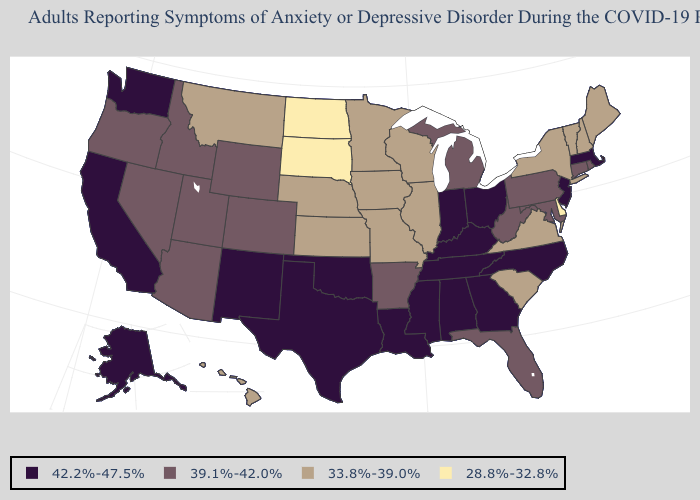Among the states that border Tennessee , does Virginia have the highest value?
Give a very brief answer. No. Which states have the lowest value in the South?
Give a very brief answer. Delaware. Is the legend a continuous bar?
Be succinct. No. How many symbols are there in the legend?
Quick response, please. 4. Which states have the highest value in the USA?
Keep it brief. Alabama, Alaska, California, Georgia, Indiana, Kentucky, Louisiana, Massachusetts, Mississippi, New Jersey, New Mexico, North Carolina, Ohio, Oklahoma, Tennessee, Texas, Washington. Name the states that have a value in the range 39.1%-42.0%?
Give a very brief answer. Arizona, Arkansas, Colorado, Connecticut, Florida, Idaho, Maryland, Michigan, Nevada, Oregon, Pennsylvania, Rhode Island, Utah, West Virginia, Wyoming. What is the value of New Mexico?
Answer briefly. 42.2%-47.5%. Name the states that have a value in the range 28.8%-32.8%?
Be succinct. Delaware, North Dakota, South Dakota. Does the first symbol in the legend represent the smallest category?
Concise answer only. No. Name the states that have a value in the range 39.1%-42.0%?
Be succinct. Arizona, Arkansas, Colorado, Connecticut, Florida, Idaho, Maryland, Michigan, Nevada, Oregon, Pennsylvania, Rhode Island, Utah, West Virginia, Wyoming. What is the value of Kansas?
Write a very short answer. 33.8%-39.0%. What is the value of Rhode Island?
Answer briefly. 39.1%-42.0%. What is the value of Minnesota?
Quick response, please. 33.8%-39.0%. What is the value of Louisiana?
Keep it brief. 42.2%-47.5%. 